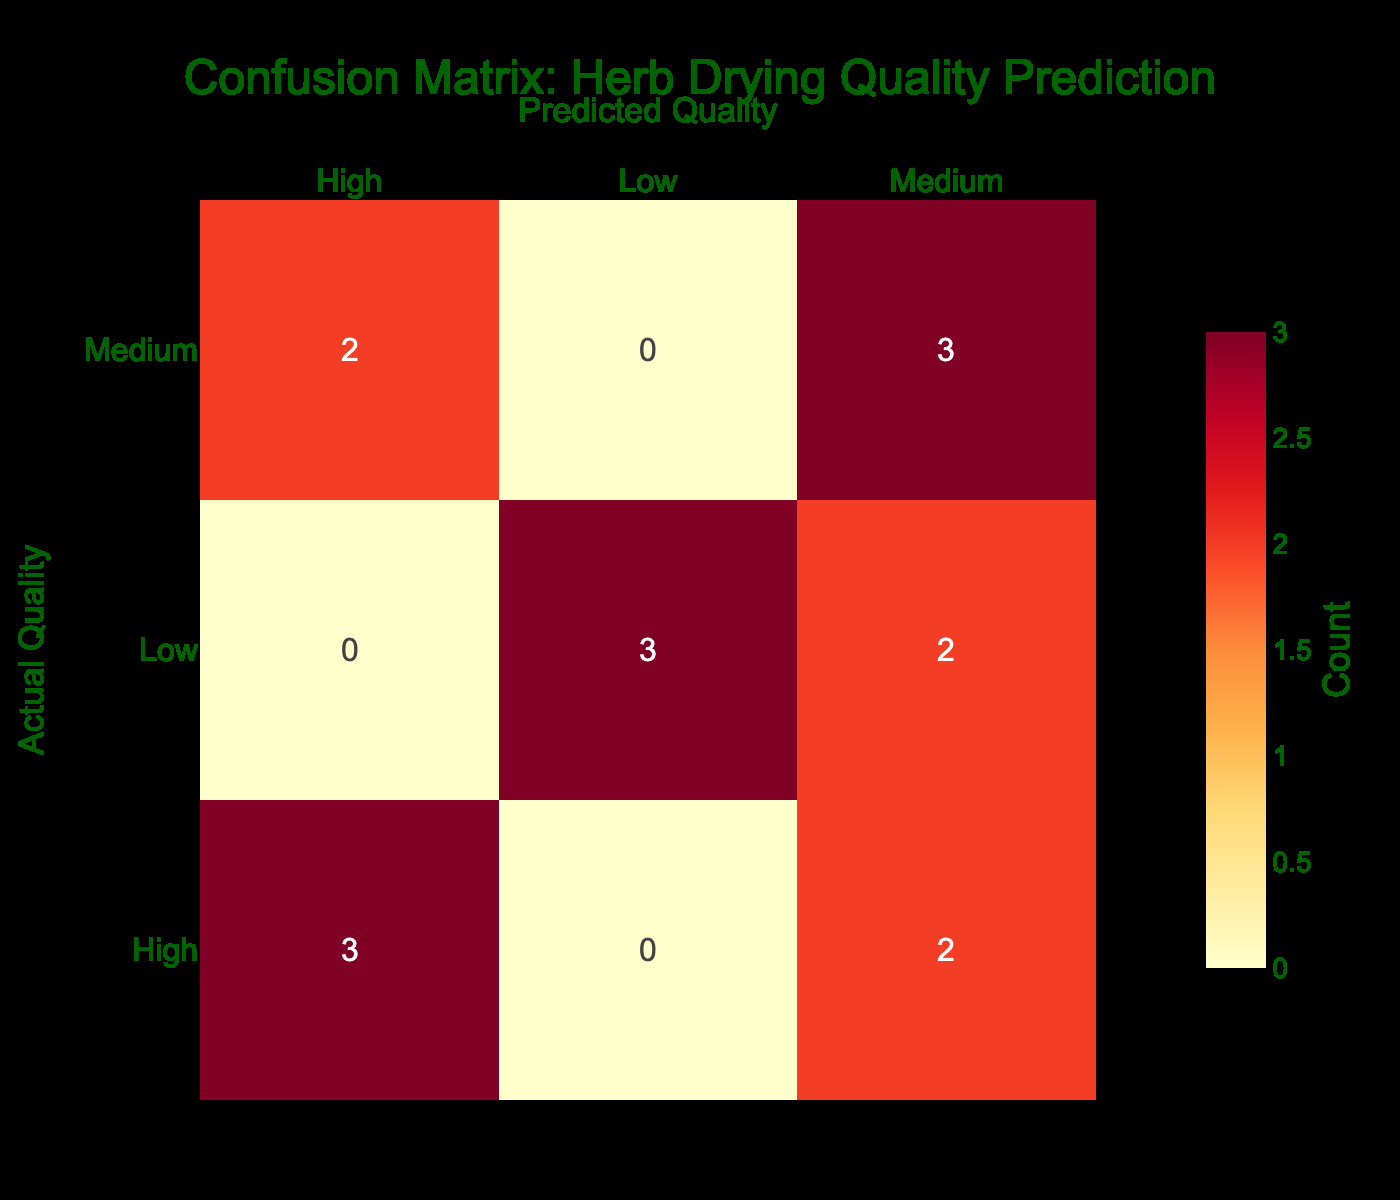What is the predicted quality when the actual quality is high for Microwave Drying? For Microwave Drying, the actual quality is high, and the table shows a predicted quality of medium.
Answer: Medium How many times did Solar Drying predict a low quality? In the case of Solar Drying, the actual quality was low, and the predicted quality was also low, resulting in a total of one instance where low quality was predicted.
Answer: 1 What is the total number of instances for Oven Drying when the actual quality is medium? Reviewing the table for Oven Drying, there are two instances where the actual quality is medium, leading to the same as the predicted quality. Therefore, the total instances for medium actual quality in Oven Drying is two.
Answer: 2 Is it true that the predicted quality was always low for Air Drying? Reviewing the rows for Air Drying, there are instances where the predicted quality was medium and high, thus it is not always low.
Answer: No What can be concluded about the effectiveness of Air Drying compared to Freeze Drying? For Air Drying, the predicted quality for high was achieved once, while for Freeze Drying, the predicted high quality was achieved twice. Thus, Freeze Drying displayed higher effectiveness compared to Air Drying based on the table data.
Answer: Freeze Drying is more effective than Air Drying 